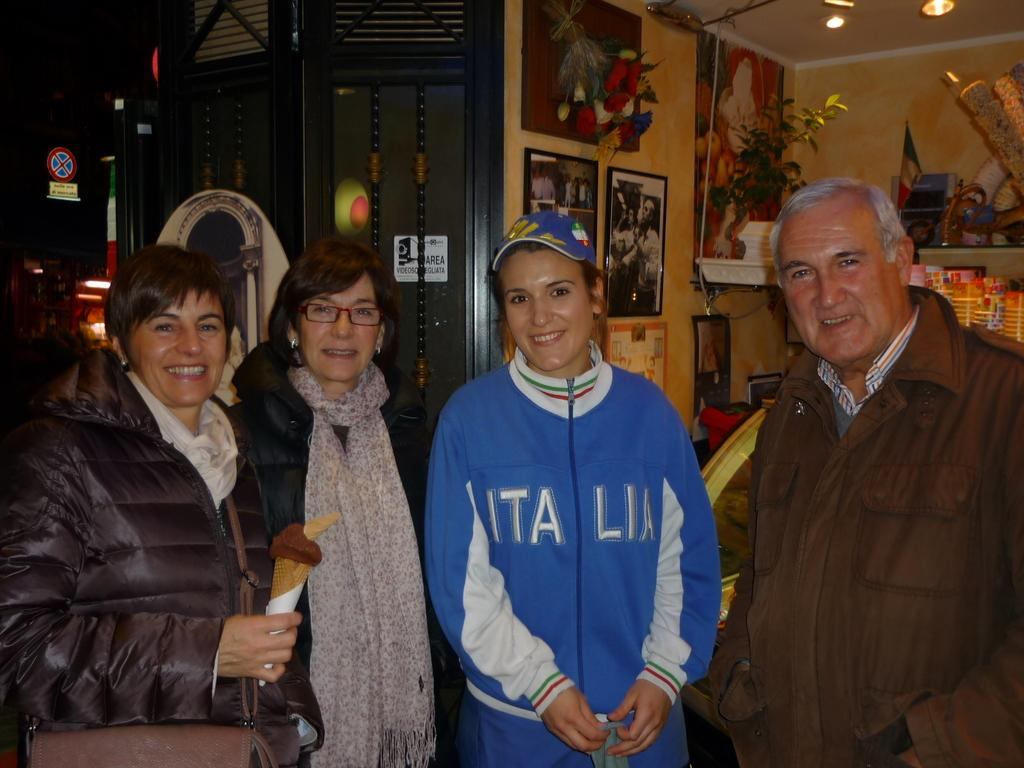<image>
Share a concise interpretation of the image provided. A woman wears a coat with Italia on the front of it. 